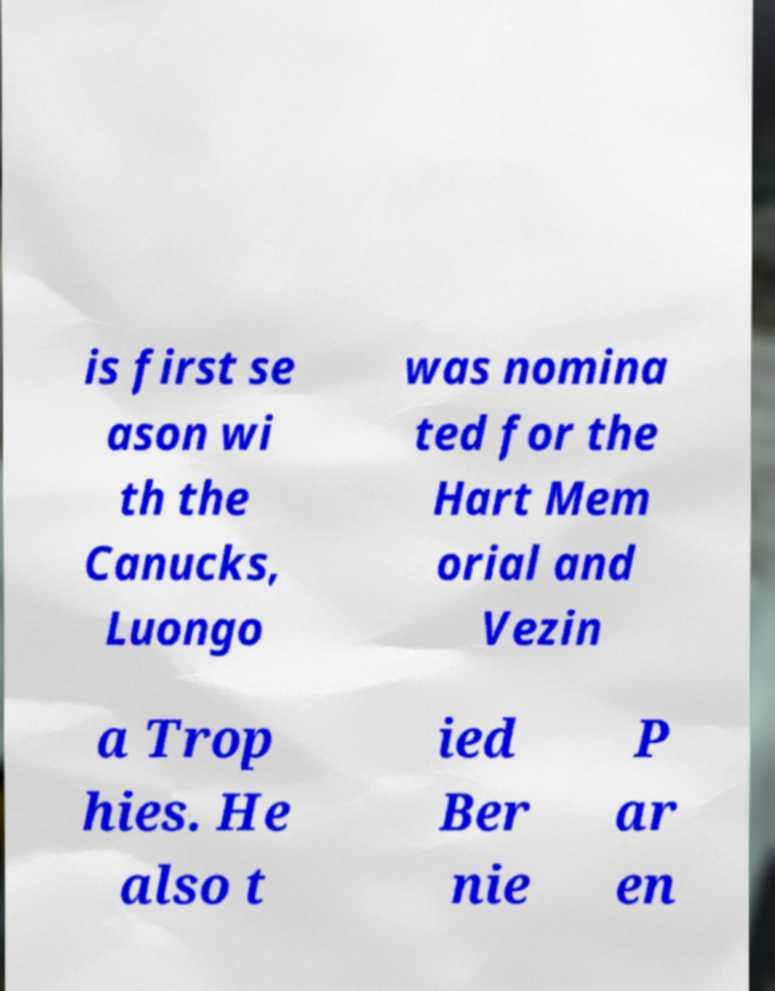Could you assist in decoding the text presented in this image and type it out clearly? is first se ason wi th the Canucks, Luongo was nomina ted for the Hart Mem orial and Vezin a Trop hies. He also t ied Ber nie P ar en 